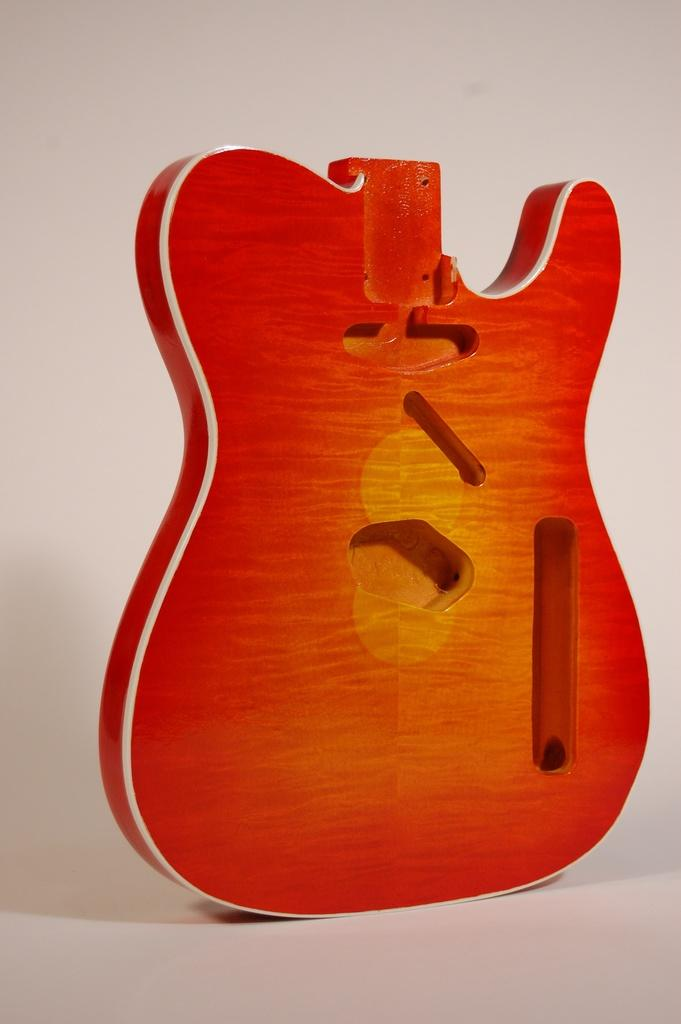What musical instrument is represented in the image? There is a part of a guitar in the image. What colors are used to depict the guitar part? The guitar part is yellow and orange in color. What is the color of the surface on which the guitar part is placed? The guitar part is on a white colored surface. What color is the background of the image? The background of the image is white. How does the wind affect the bead in the image? There is no wind or bead present in the image; it features a part of a guitar on a white surface with a white background. 